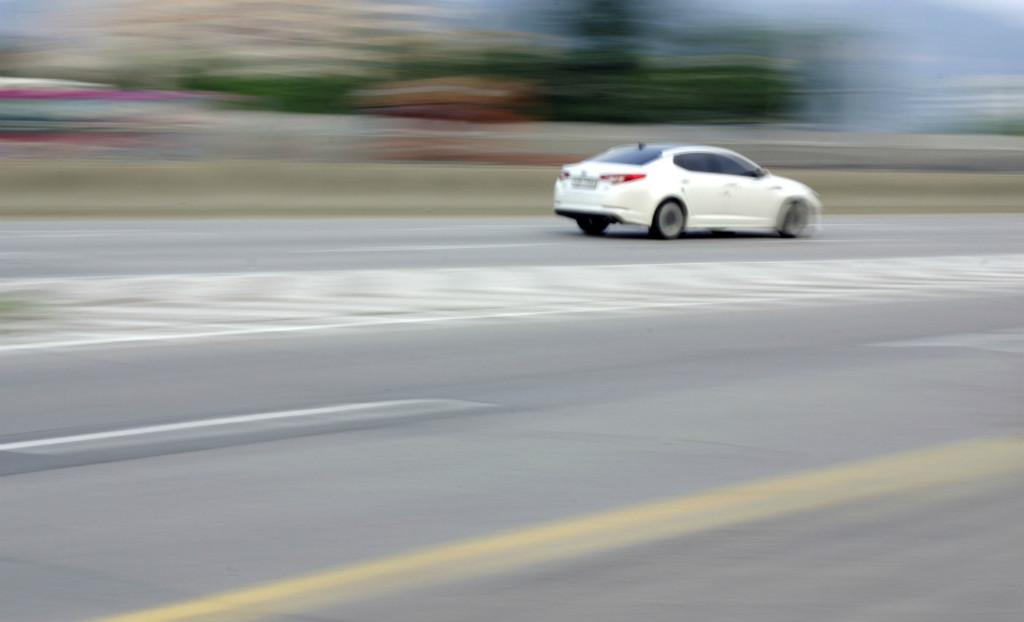Where was the image taken? The image is taken outside. What is the main subject in the middle of the image? There is a car in the middle of the image. What color is the car? The car is white in color. Can you see any tombstones or graves in the image? There are no tombstones or graves present in the image; it features a white car in an outdoor setting. 